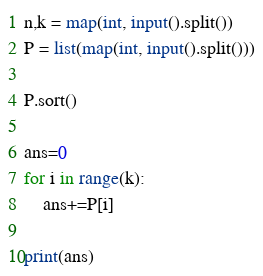<code> <loc_0><loc_0><loc_500><loc_500><_Python_>n,k = map(int, input().split())
P = list(map(int, input().split()))

P.sort()

ans=0
for i in range(k):
    ans+=P[i]

print(ans)

</code> 